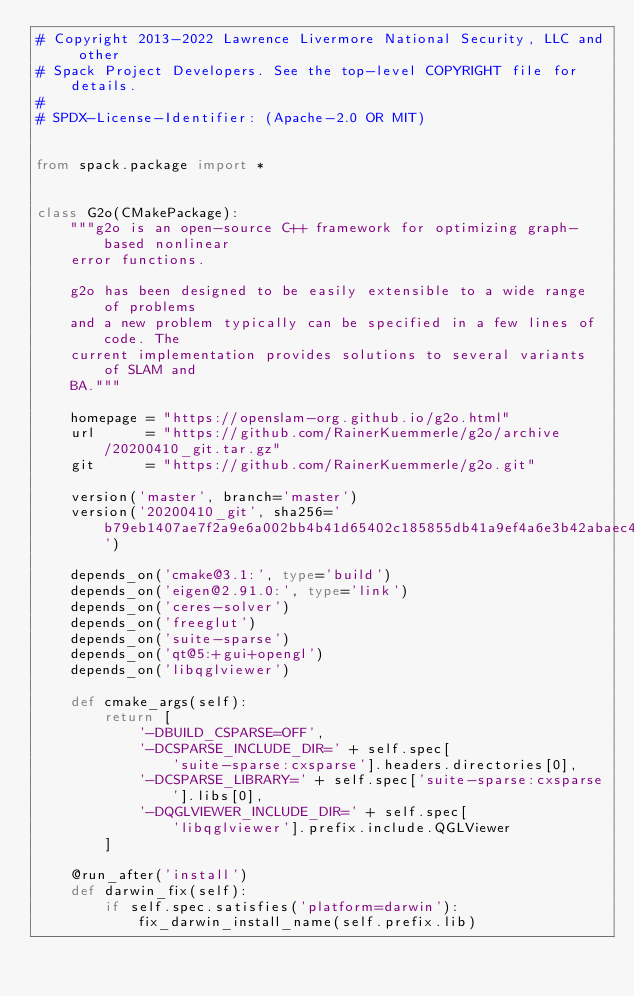<code> <loc_0><loc_0><loc_500><loc_500><_Python_># Copyright 2013-2022 Lawrence Livermore National Security, LLC and other
# Spack Project Developers. See the top-level COPYRIGHT file for details.
#
# SPDX-License-Identifier: (Apache-2.0 OR MIT)


from spack.package import *


class G2o(CMakePackage):
    """g2o is an open-source C++ framework for optimizing graph-based nonlinear
    error functions.

    g2o has been designed to be easily extensible to a wide range of problems
    and a new problem typically can be specified in a few lines of code. The
    current implementation provides solutions to several variants of SLAM and
    BA."""

    homepage = "https://openslam-org.github.io/g2o.html"
    url      = "https://github.com/RainerKuemmerle/g2o/archive/20200410_git.tar.gz"
    git      = "https://github.com/RainerKuemmerle/g2o.git"

    version('master', branch='master')
    version('20200410_git', sha256='b79eb1407ae7f2a9e6a002bb4b41d65402c185855db41a9ef4a6e3b42abaec4c')

    depends_on('cmake@3.1:', type='build')
    depends_on('eigen@2.91.0:', type='link')
    depends_on('ceres-solver')
    depends_on('freeglut')
    depends_on('suite-sparse')
    depends_on('qt@5:+gui+opengl')
    depends_on('libqglviewer')

    def cmake_args(self):
        return [
            '-DBUILD_CSPARSE=OFF',
            '-DCSPARSE_INCLUDE_DIR=' + self.spec[
                'suite-sparse:cxsparse'].headers.directories[0],
            '-DCSPARSE_LIBRARY=' + self.spec['suite-sparse:cxsparse'].libs[0],
            '-DQGLVIEWER_INCLUDE_DIR=' + self.spec[
                'libqglviewer'].prefix.include.QGLViewer
        ]

    @run_after('install')
    def darwin_fix(self):
        if self.spec.satisfies('platform=darwin'):
            fix_darwin_install_name(self.prefix.lib)
</code> 